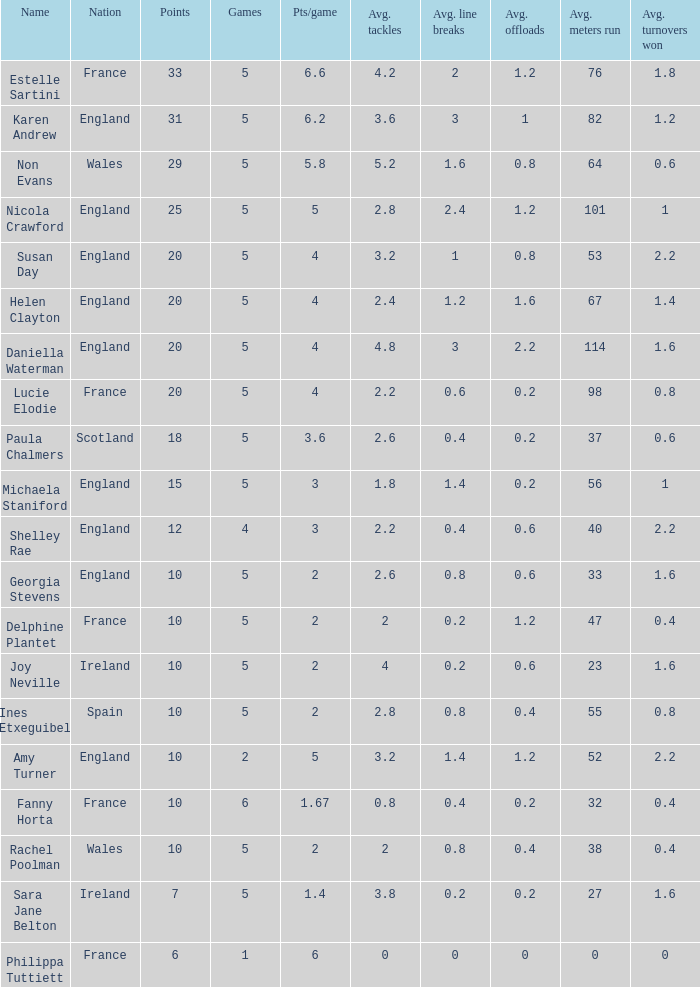Can you tell me the average Points that has a Pts/game larger than 4, and the Nation of england, and the Games smaller than 5? 10.0. 